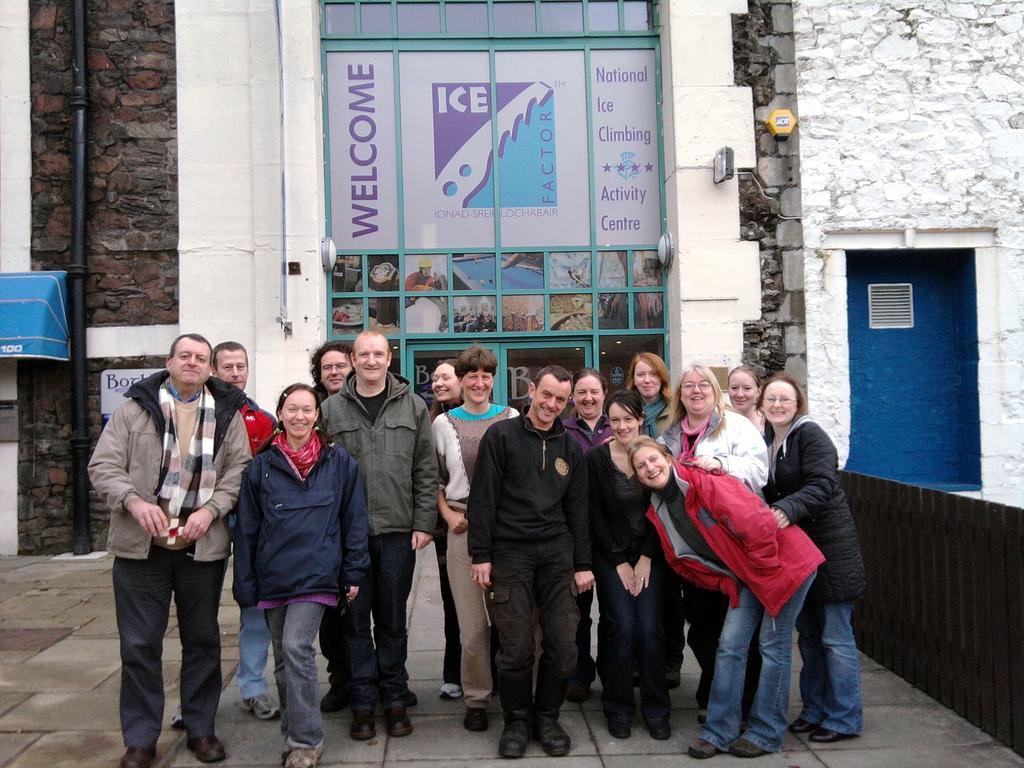How would you summarize this image in a sentence or two? In this image we can see people standing and smiling on the road. In the background there are buildings, pipeline, fence and an advertisement. 